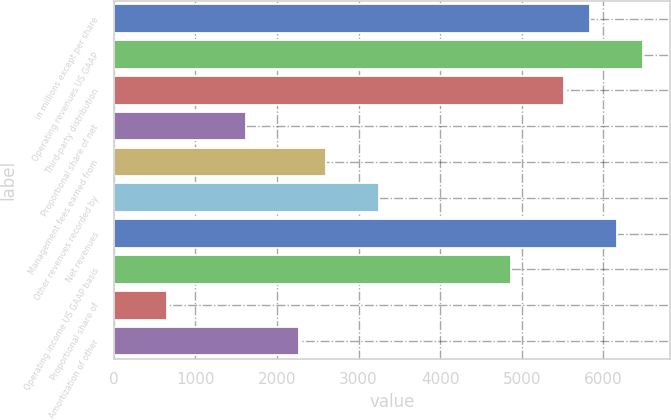<chart> <loc_0><loc_0><loc_500><loc_500><bar_chart><fcel>in millions except per share<fcel>Operating revenues US GAAP<fcel>Third-party distribution<fcel>Proportional share of net<fcel>Management fees earned from<fcel>Other revenues recorded by<fcel>Net revenues<fcel>Operating income US GAAP basis<fcel>Proportional share of<fcel>Amortization of other<nl><fcel>5843.09<fcel>6492.19<fcel>5518.54<fcel>1623.94<fcel>2597.59<fcel>3246.69<fcel>6167.64<fcel>4869.44<fcel>650.29<fcel>2273.04<nl></chart> 